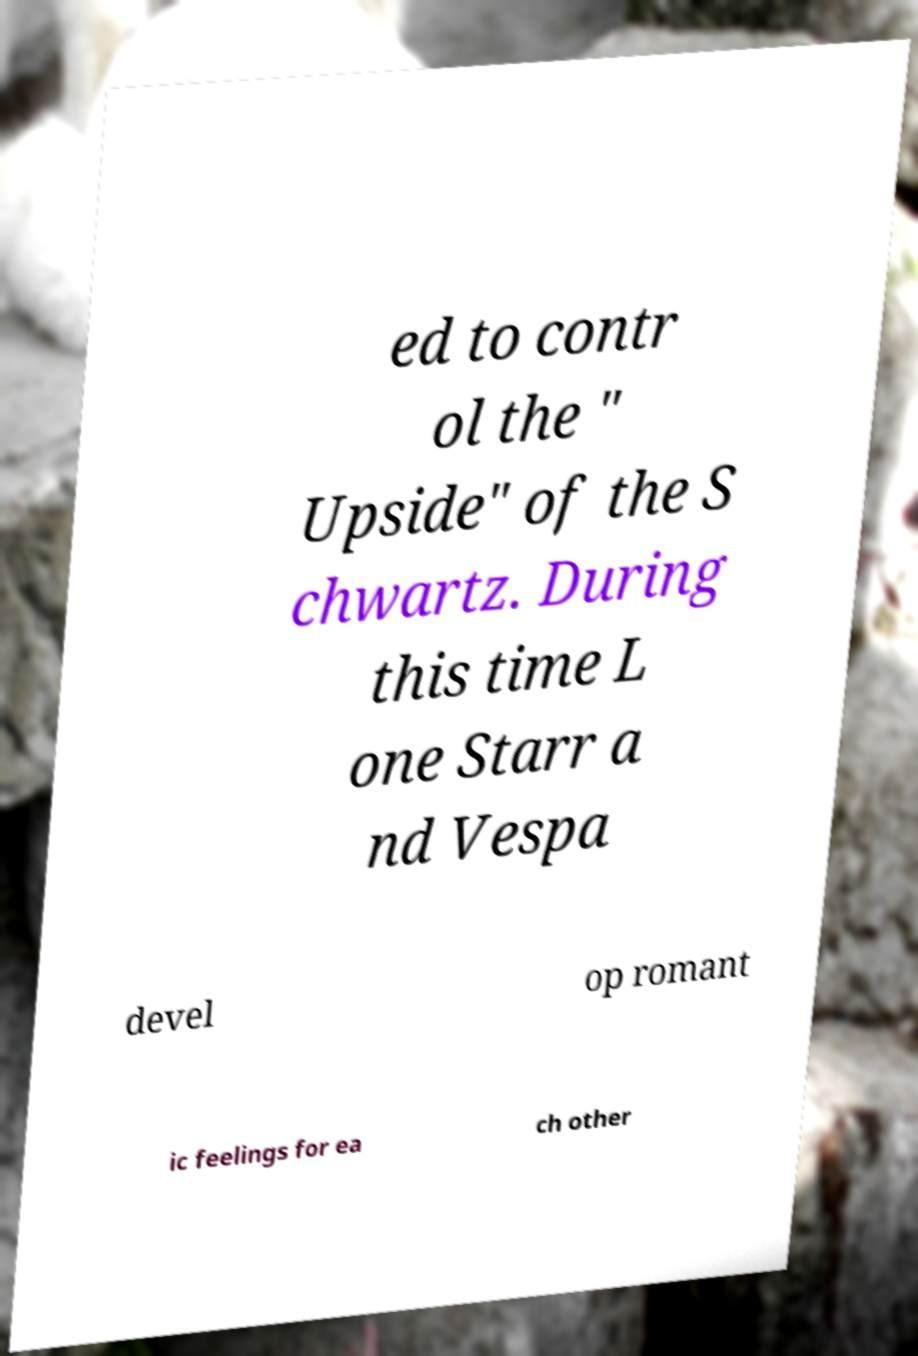Please read and relay the text visible in this image. What does it say? ed to contr ol the " Upside" of the S chwartz. During this time L one Starr a nd Vespa devel op romant ic feelings for ea ch other 